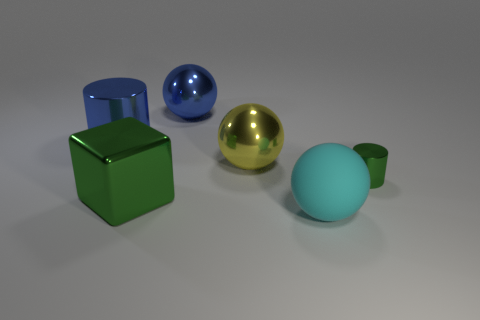There is a large shiny thing behind the blue cylinder; is it the same shape as the cyan object?
Give a very brief answer. Yes. Does the large green thing have the same material as the cyan object?
Offer a terse response. No. What number of large matte spheres are behind the blue metal object on the right side of the metal cylinder to the left of the big green block?
Your answer should be compact. 0. What number of purple balls are there?
Your answer should be compact. 0. Is the number of big cubes that are right of the big matte sphere less than the number of green metal things right of the large blue cylinder?
Provide a short and direct response. Yes. Are there fewer yellow shiny things left of the large green metallic block than large blue metal cubes?
Make the answer very short. No. There is a thing in front of the green metallic object that is on the left side of the shiny cylinder that is right of the yellow metallic sphere; what is it made of?
Ensure brevity in your answer.  Rubber. What number of things are large objects that are left of the large yellow shiny thing or shiny objects that are behind the small green shiny thing?
Offer a very short reply. 4. What material is the cyan object that is the same shape as the large yellow metal object?
Provide a succinct answer. Rubber. How many metallic objects are either tiny green things or small blue cubes?
Your response must be concise. 1. 